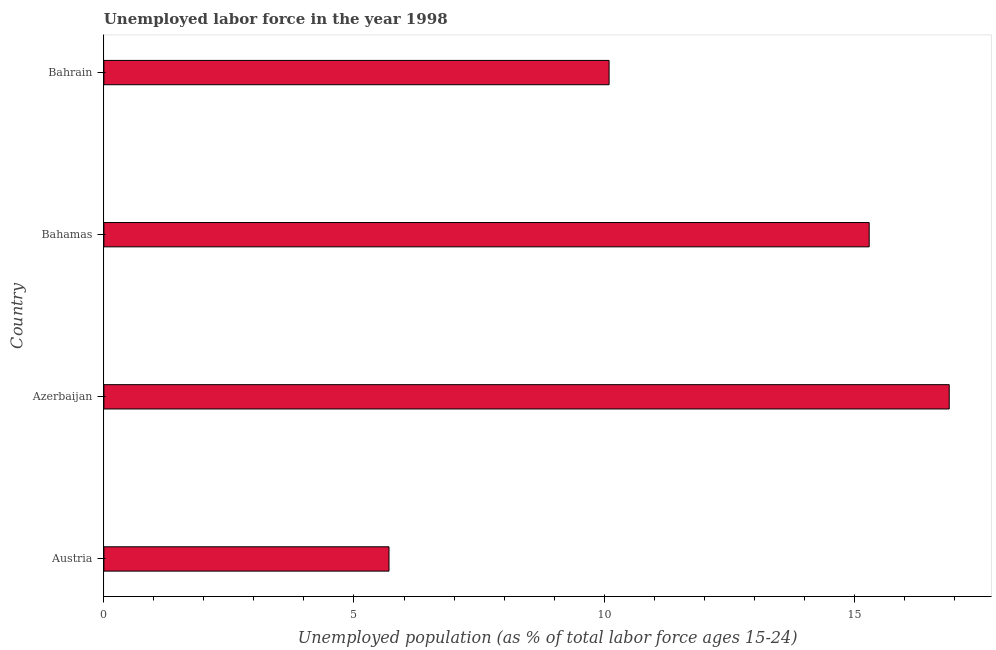What is the title of the graph?
Make the answer very short. Unemployed labor force in the year 1998. What is the label or title of the X-axis?
Provide a short and direct response. Unemployed population (as % of total labor force ages 15-24). What is the label or title of the Y-axis?
Ensure brevity in your answer.  Country. What is the total unemployed youth population in Bahrain?
Offer a very short reply. 10.1. Across all countries, what is the maximum total unemployed youth population?
Ensure brevity in your answer.  16.9. Across all countries, what is the minimum total unemployed youth population?
Provide a succinct answer. 5.7. In which country was the total unemployed youth population maximum?
Ensure brevity in your answer.  Azerbaijan. What is the sum of the total unemployed youth population?
Keep it short and to the point. 48. What is the average total unemployed youth population per country?
Give a very brief answer. 12. What is the median total unemployed youth population?
Provide a succinct answer. 12.7. What is the ratio of the total unemployed youth population in Azerbaijan to that in Bahamas?
Ensure brevity in your answer.  1.1. What is the difference between the highest and the lowest total unemployed youth population?
Your response must be concise. 11.2. In how many countries, is the total unemployed youth population greater than the average total unemployed youth population taken over all countries?
Offer a terse response. 2. How many bars are there?
Your answer should be compact. 4. Are all the bars in the graph horizontal?
Offer a terse response. Yes. How many countries are there in the graph?
Provide a short and direct response. 4. Are the values on the major ticks of X-axis written in scientific E-notation?
Your answer should be very brief. No. What is the Unemployed population (as % of total labor force ages 15-24) of Austria?
Ensure brevity in your answer.  5.7. What is the Unemployed population (as % of total labor force ages 15-24) of Azerbaijan?
Offer a terse response. 16.9. What is the Unemployed population (as % of total labor force ages 15-24) in Bahamas?
Your answer should be compact. 15.3. What is the Unemployed population (as % of total labor force ages 15-24) of Bahrain?
Your answer should be compact. 10.1. What is the difference between the Unemployed population (as % of total labor force ages 15-24) in Austria and Azerbaijan?
Your answer should be compact. -11.2. What is the difference between the Unemployed population (as % of total labor force ages 15-24) in Austria and Bahamas?
Ensure brevity in your answer.  -9.6. What is the difference between the Unemployed population (as % of total labor force ages 15-24) in Austria and Bahrain?
Provide a short and direct response. -4.4. What is the difference between the Unemployed population (as % of total labor force ages 15-24) in Azerbaijan and Bahamas?
Your response must be concise. 1.6. What is the difference between the Unemployed population (as % of total labor force ages 15-24) in Bahamas and Bahrain?
Your answer should be very brief. 5.2. What is the ratio of the Unemployed population (as % of total labor force ages 15-24) in Austria to that in Azerbaijan?
Keep it short and to the point. 0.34. What is the ratio of the Unemployed population (as % of total labor force ages 15-24) in Austria to that in Bahamas?
Ensure brevity in your answer.  0.37. What is the ratio of the Unemployed population (as % of total labor force ages 15-24) in Austria to that in Bahrain?
Your response must be concise. 0.56. What is the ratio of the Unemployed population (as % of total labor force ages 15-24) in Azerbaijan to that in Bahamas?
Provide a succinct answer. 1.1. What is the ratio of the Unemployed population (as % of total labor force ages 15-24) in Azerbaijan to that in Bahrain?
Your answer should be compact. 1.67. What is the ratio of the Unemployed population (as % of total labor force ages 15-24) in Bahamas to that in Bahrain?
Ensure brevity in your answer.  1.51. 